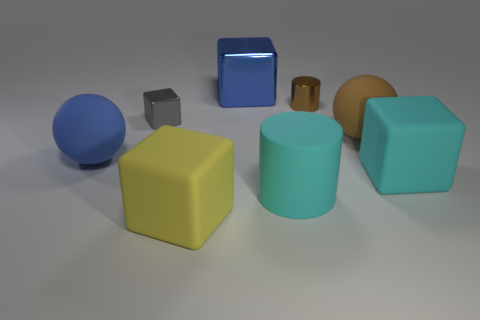Is the number of cyan matte things less than the number of big blocks?
Provide a short and direct response. Yes. Are there more blue matte spheres left of the tiny cylinder than big rubber things in front of the yellow rubber thing?
Offer a terse response. Yes. Do the brown cylinder and the large blue block have the same material?
Offer a very short reply. Yes. There is a large blue object in front of the brown sphere; what number of tiny metal cylinders are on the left side of it?
Keep it short and to the point. 0. There is a ball that is left of the blue metal block; is its color the same as the large matte cylinder?
Offer a very short reply. No. What number of things are either small purple matte spheres or large things that are right of the big yellow matte block?
Ensure brevity in your answer.  4. There is a big blue object that is behind the large blue sphere; is its shape the same as the large cyan object on the left side of the big brown object?
Your response must be concise. No. Is there anything else that has the same color as the small shiny cylinder?
Offer a terse response. Yes. What shape is the tiny brown object that is made of the same material as the blue cube?
Offer a very short reply. Cylinder. The thing that is to the right of the blue metallic cube and in front of the large cyan matte block is made of what material?
Provide a short and direct response. Rubber. 